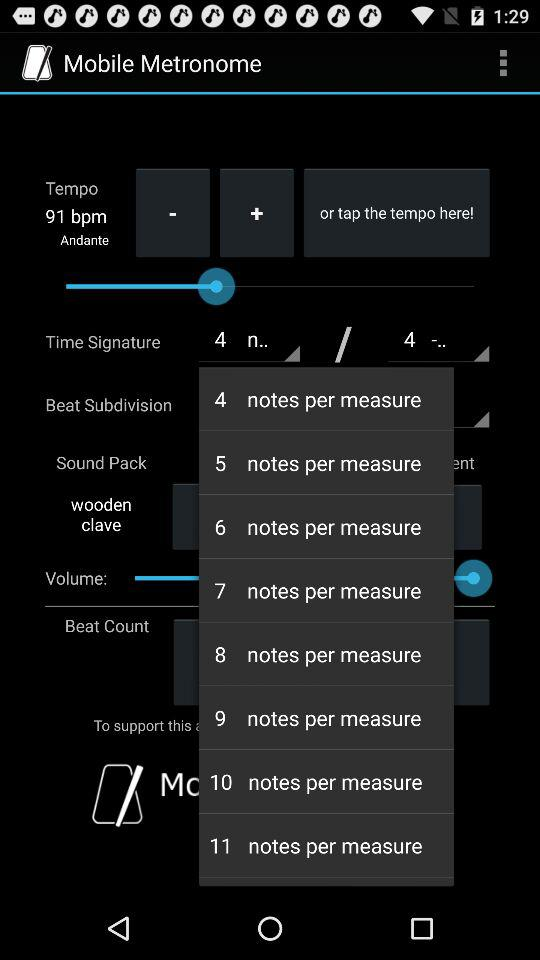What's the tempo? The tempo is 91 bpm. 